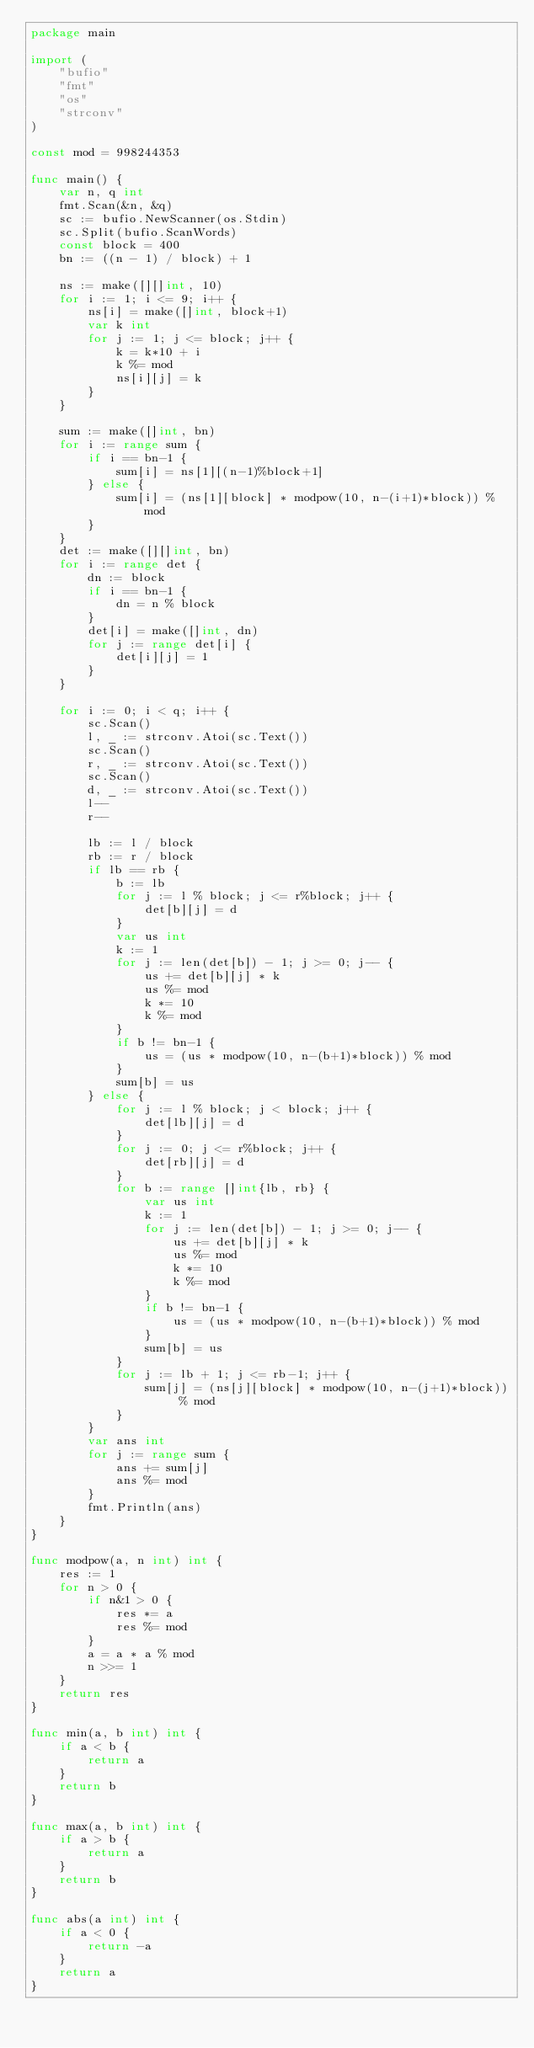<code> <loc_0><loc_0><loc_500><loc_500><_Go_>package main

import (
	"bufio"
	"fmt"
	"os"
	"strconv"
)

const mod = 998244353

func main() {
	var n, q int
	fmt.Scan(&n, &q)
	sc := bufio.NewScanner(os.Stdin)
	sc.Split(bufio.ScanWords)
	const block = 400
	bn := ((n - 1) / block) + 1

	ns := make([][]int, 10)
	for i := 1; i <= 9; i++ {
		ns[i] = make([]int, block+1)
		var k int
		for j := 1; j <= block; j++ {
			k = k*10 + i
			k %= mod
			ns[i][j] = k
		}
	}

	sum := make([]int, bn)
	for i := range sum {
		if i == bn-1 {
			sum[i] = ns[1][(n-1)%block+1]
		} else {
			sum[i] = (ns[1][block] * modpow(10, n-(i+1)*block)) % mod
		}
	}
	det := make([][]int, bn)
	for i := range det {
		dn := block
		if i == bn-1 {
			dn = n % block
		}
		det[i] = make([]int, dn)
		for j := range det[i] {
			det[i][j] = 1
		}
	}

	for i := 0; i < q; i++ {
		sc.Scan()
		l, _ := strconv.Atoi(sc.Text())
		sc.Scan()
		r, _ := strconv.Atoi(sc.Text())
		sc.Scan()
		d, _ := strconv.Atoi(sc.Text())
		l--
		r--

		lb := l / block
		rb := r / block
		if lb == rb {
			b := lb
			for j := l % block; j <= r%block; j++ {
				det[b][j] = d
			}
			var us int
			k := 1
			for j := len(det[b]) - 1; j >= 0; j-- {
				us += det[b][j] * k
				us %= mod
				k *= 10
				k %= mod
			}
			if b != bn-1 {
				us = (us * modpow(10, n-(b+1)*block)) % mod
			}
			sum[b] = us
		} else {
			for j := l % block; j < block; j++ {
				det[lb][j] = d
			}
			for j := 0; j <= r%block; j++ {
				det[rb][j] = d
			}
			for b := range []int{lb, rb} {
				var us int
				k := 1
				for j := len(det[b]) - 1; j >= 0; j-- {
					us += det[b][j] * k
					us %= mod
					k *= 10
					k %= mod
				}
				if b != bn-1 {
					us = (us * modpow(10, n-(b+1)*block)) % mod
				}
				sum[b] = us
			}
			for j := lb + 1; j <= rb-1; j++ {
				sum[j] = (ns[j][block] * modpow(10, n-(j+1)*block)) % mod
			}
		}
		var ans int
		for j := range sum {
			ans += sum[j]
			ans %= mod
		}
		fmt.Println(ans)
	}
}

func modpow(a, n int) int {
	res := 1
	for n > 0 {
		if n&1 > 0 {
			res *= a
			res %= mod
		}
		a = a * a % mod
		n >>= 1
	}
	return res
}

func min(a, b int) int {
	if a < b {
		return a
	}
	return b
}

func max(a, b int) int {
	if a > b {
		return a
	}
	return b
}

func abs(a int) int {
	if a < 0 {
		return -a
	}
	return a
}
</code> 